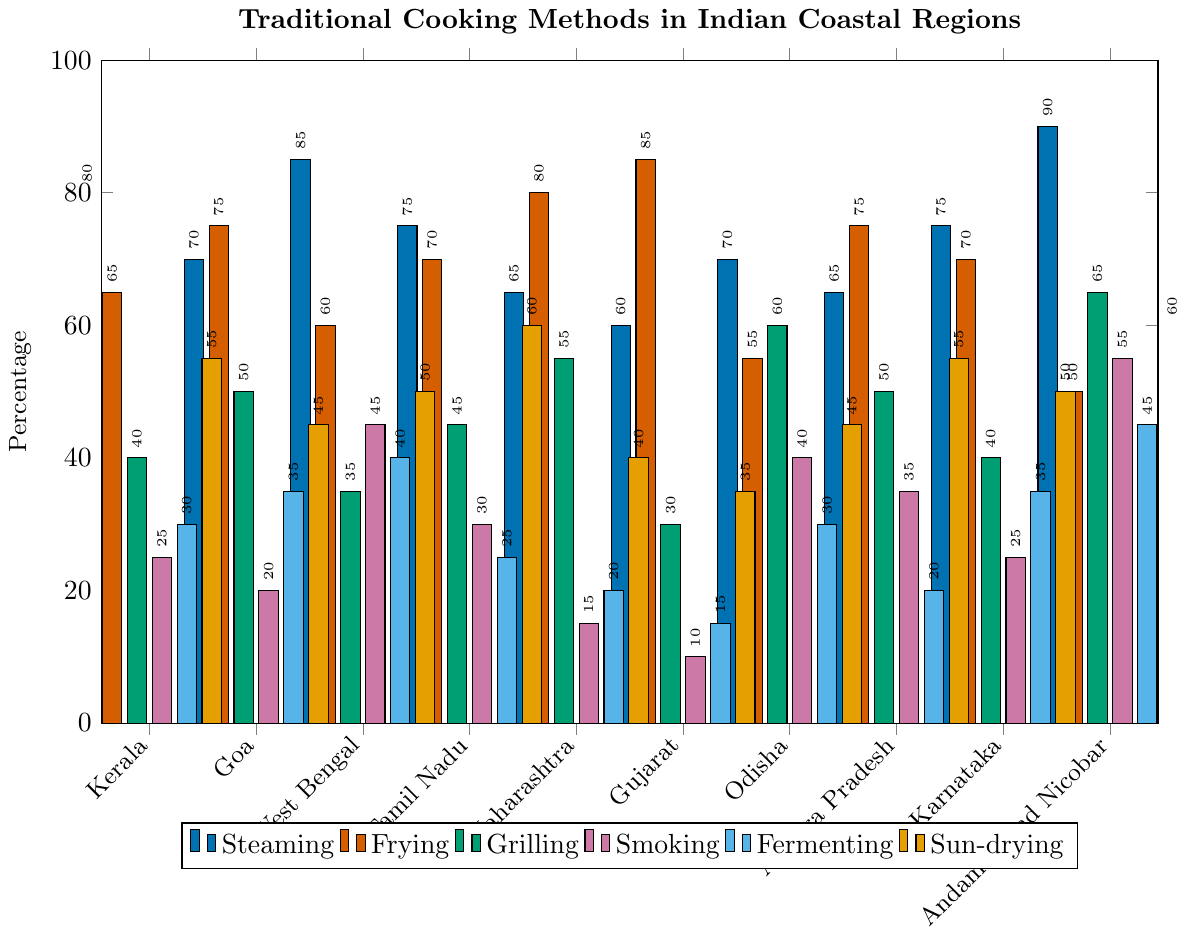Which region has the highest percentage of steaming? To find the region with the highest percentage of steaming, locate the tallest blue bar in the steaming category which represents the Andaman and Nicobar region.
Answer: Andaman and Nicobar Which region has a higher percentage of smoking: West Bengal or Tamil Nadu? Compare the heights of the red bars for West Bengal and Tamil Nadu in the smoking category, where West Bengal has 45% and Tamil Nadu has 30%.
Answer: West Bengal What is the combined percentage of grilling and fermenting for Goa? Identify the values for grilling (50%) and fermenting (35%) in Goa, then add these values (50% + 35%).
Answer: 85% Which coastal region has the equal percentage of steaming and grilling? Check each region to see if the values for steaming and grilling match. No region has exactly equal values for steaming and grilling, thus the answer is none.
Answer: None What is the average percentage of sun-drying across all regions? Sum the percentages of sun-drying for all regions and then divide by the number of regions: (55 + 45 + 50 + 60 + 40 + 35 + 45 + 55 + 50 + 60) / 10 = 495 / 10
Answer: 49.5 Which cooking method is most commonly used in Maharashtra? Identify the cooking method with the highest bar for Maharashtra. Frying has an 80% usage, which is the tallest bar.
Answer: Frying Between Kerala and Karnataka, which region has less percentage of fermenting? Compare the heights of the purple bars for fermenting in Kerala (30%) and Karnataka (35%).
Answer: Kerala Is the percentage of frying higher in Gujarat or Andhra Pradesh? Compare the heights of the orange bars representing frying in Gujarat (85%) and Andhra Pradesh (75%).
Answer: Gujarat What is the range of the grilling percentages across all regions? Determine the highest and lowest values for grilling: highest (Andaman and Nicobar 65%), lowest (Gujarat 30%), then find their difference (65% - 30%).
Answer: 35% Does any region use smoking more than steaming? Compare the smoking (red bars) and steaming (blue bars) percentages for each region. No region has smoking values higher than steaming values.
Answer: No 